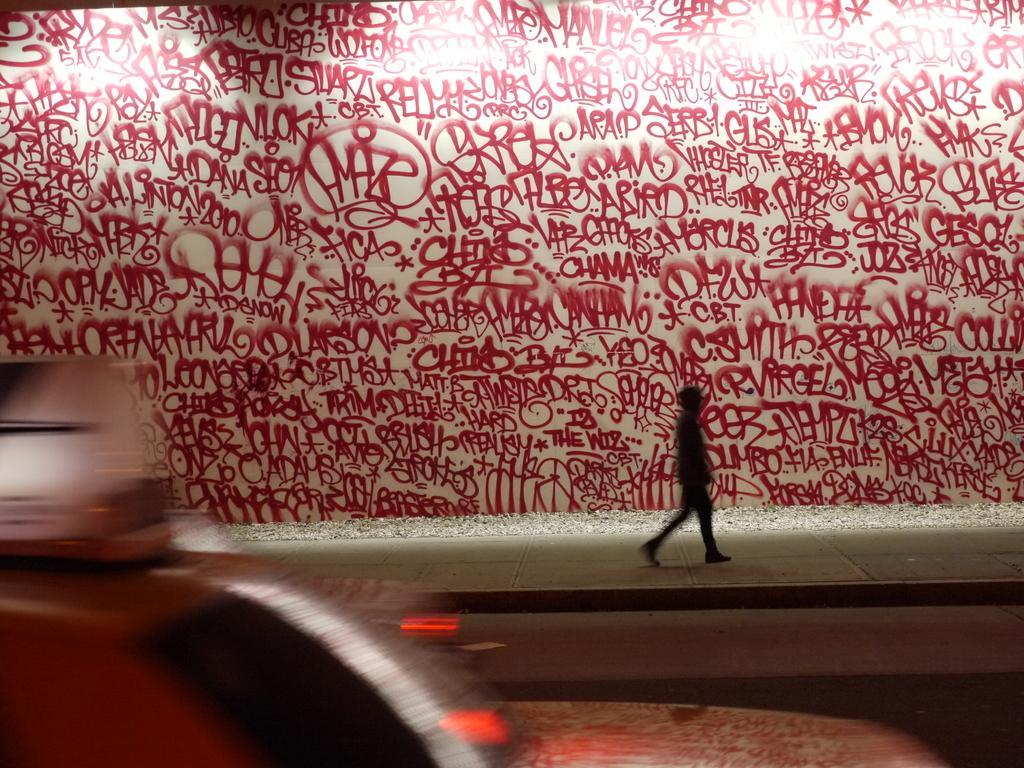Can you describe this image briefly? In the given image i can see a text written on the wall. 